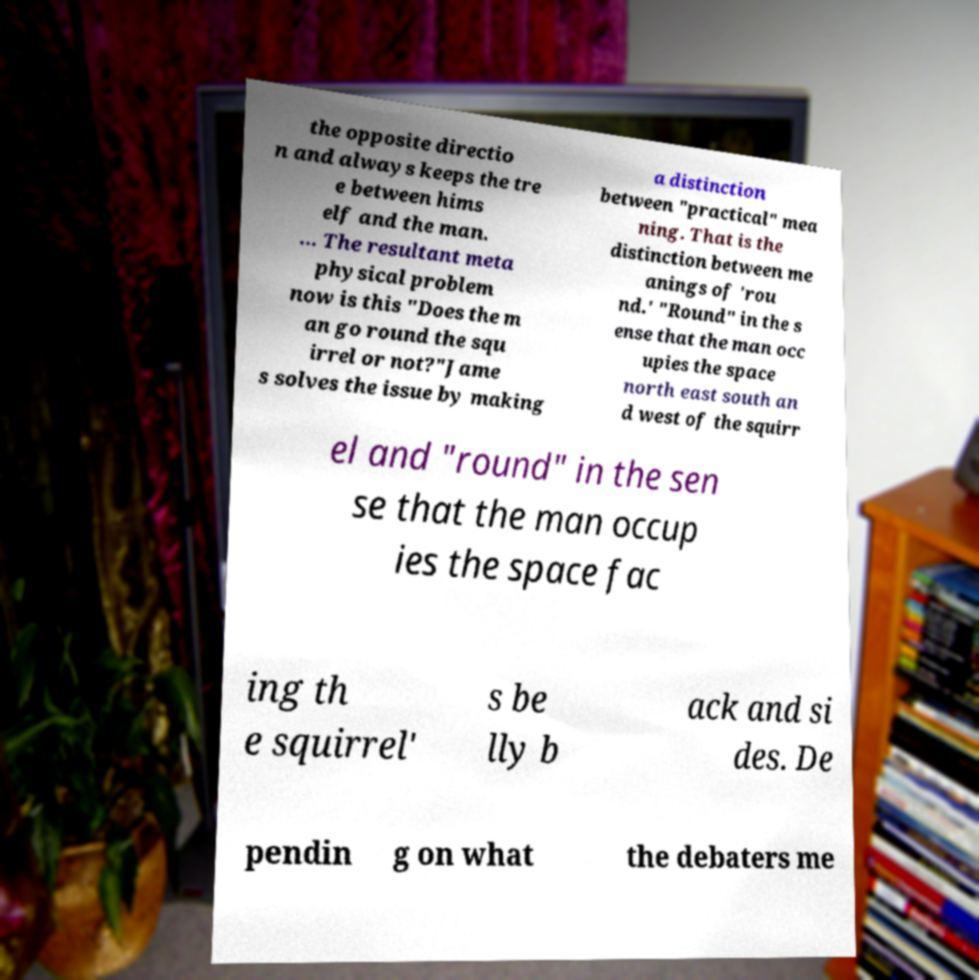Can you read and provide the text displayed in the image?This photo seems to have some interesting text. Can you extract and type it out for me? the opposite directio n and always keeps the tre e between hims elf and the man. … The resultant meta physical problem now is this "Does the m an go round the squ irrel or not?"Jame s solves the issue by making a distinction between "practical" mea ning. That is the distinction between me anings of 'rou nd.' "Round" in the s ense that the man occ upies the space north east south an d west of the squirr el and "round" in the sen se that the man occup ies the space fac ing th e squirrel' s be lly b ack and si des. De pendin g on what the debaters me 